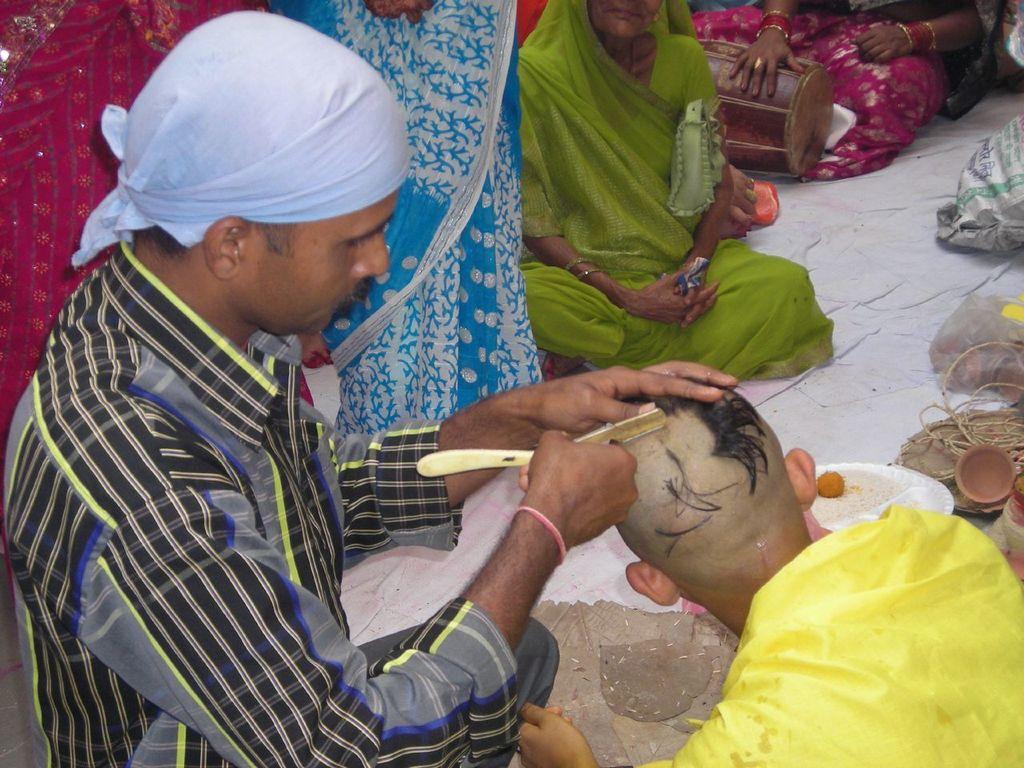Describe this image in one or two sentences. In this image I can see number of people where few are standing and few are sitting. In the front I can see one man is holding a salon razor and I can also see a handkerchief on his head. On the right side of this image I can see a plate, a basket, a bag and few other stuffs. On the top right side of this image I can see a musical instrument. 